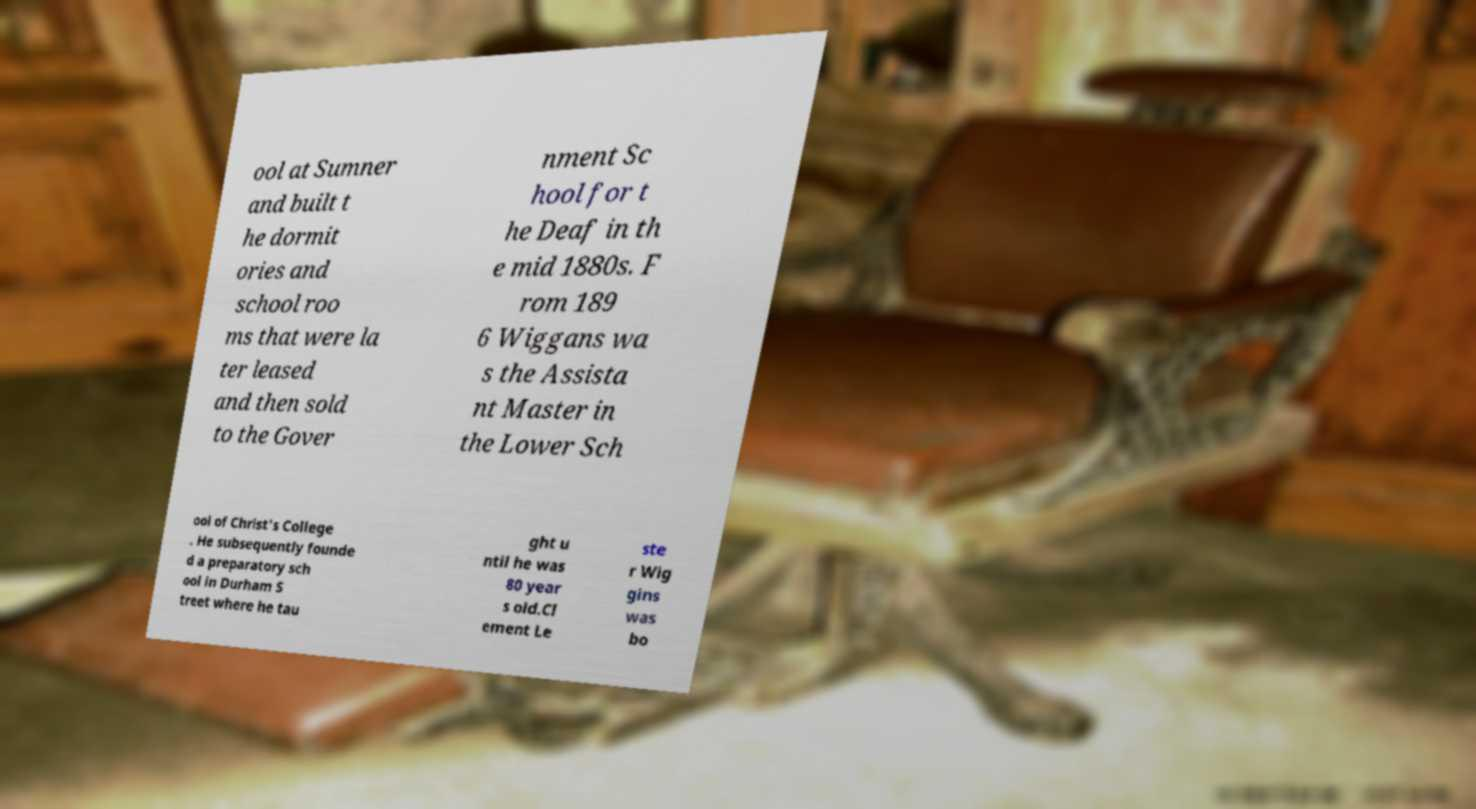What messages or text are displayed in this image? I need them in a readable, typed format. ool at Sumner and built t he dormit ories and school roo ms that were la ter leased and then sold to the Gover nment Sc hool for t he Deaf in th e mid 1880s. F rom 189 6 Wiggans wa s the Assista nt Master in the Lower Sch ool of Christ's College . He subsequently founde d a preparatory sch ool in Durham S treet where he tau ght u ntil he was 80 year s old.Cl ement Le ste r Wig gins was bo 